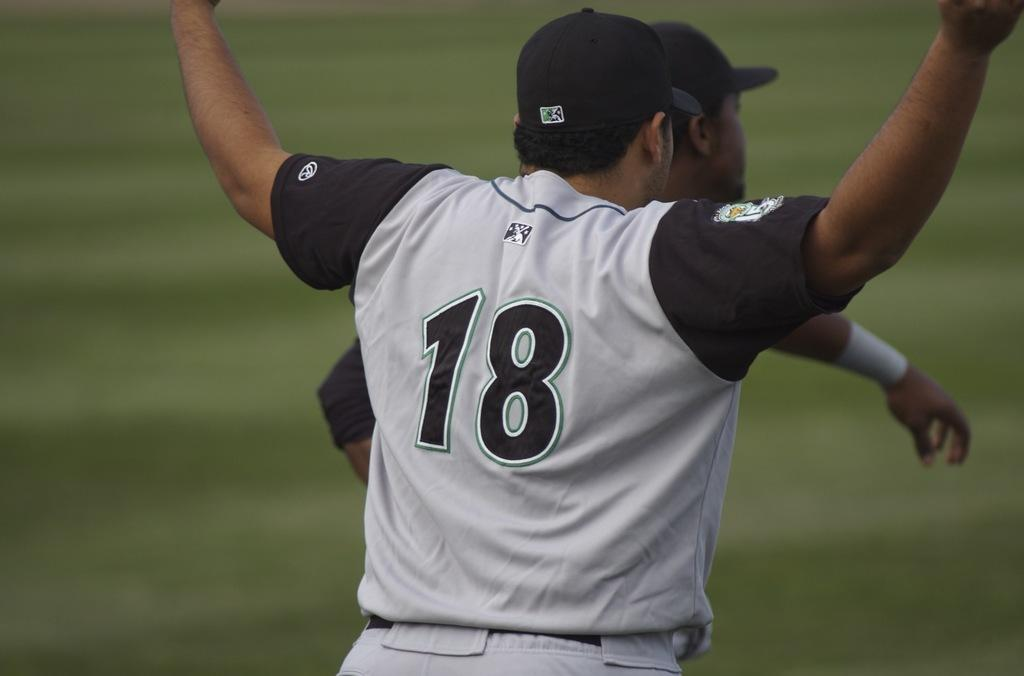<image>
Write a terse but informative summary of the picture. A baseball player wearing number 18 with his hands in the air. 